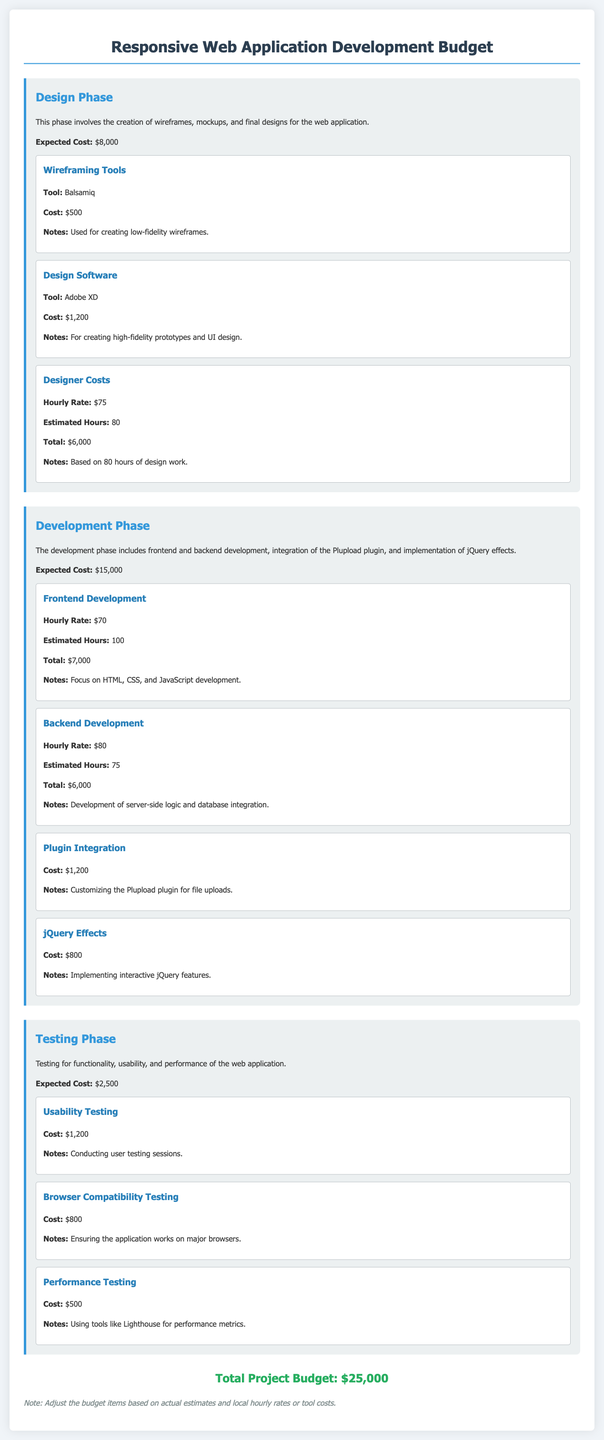What is the total budget for the project? The total budget for the project is listed at the bottom of the document, combining all phases' costs.
Answer: $25,000 What is the expected cost for the Design Phase? The expected cost for the Design Phase is specifically mentioned under that section of the document.
Answer: $8,000 How much is allocated for Usability Testing? The cost for Usability Testing is indicated in the Testing Phase section of the budget.
Answer: $1,200 What is the hourly rate for Backend Development? The hourly rate for Backend Development is provided within the Development Phase details.
Answer: $80 How many estimated hours are dedicated to Frontend Development? The estimated hours for Frontend Development can be found in the Development Phase breakdown.
Answer: 100 What is the total cost for Designer Costs in the Design Phase? The total cost for Designer Costs is calculated based on hours worked and the hourly rate mentioned.
Answer: $6,000 What tool is used for wireframing? The tool assigned for wireframing is explicitly mentioned in the Design Phase component.
Answer: Balsamiq How much is the cost for Plugin Integration? The cost for Plugin Integration is listed in the Development Phase section of the document.
Answer: $1,200 What is the expected cost for the Testing Phase? The expected cost for the Testing Phase is noted in that section of the budget.
Answer: $2,500 